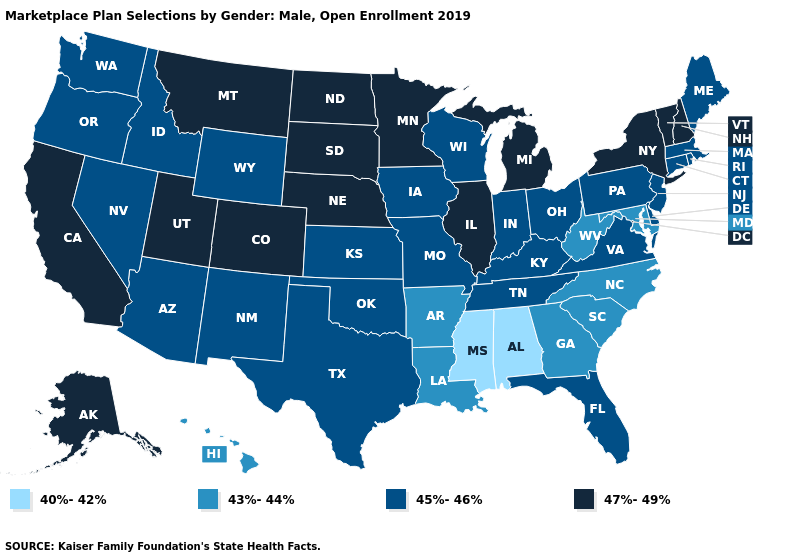Among the states that border Texas , which have the highest value?
Concise answer only. New Mexico, Oklahoma. Does Iowa have the lowest value in the USA?
Answer briefly. No. Name the states that have a value in the range 45%-46%?
Be succinct. Arizona, Connecticut, Delaware, Florida, Idaho, Indiana, Iowa, Kansas, Kentucky, Maine, Massachusetts, Missouri, Nevada, New Jersey, New Mexico, Ohio, Oklahoma, Oregon, Pennsylvania, Rhode Island, Tennessee, Texas, Virginia, Washington, Wisconsin, Wyoming. Does the first symbol in the legend represent the smallest category?
Write a very short answer. Yes. What is the value of Maine?
Answer briefly. 45%-46%. Name the states that have a value in the range 40%-42%?
Answer briefly. Alabama, Mississippi. What is the value of Ohio?
Concise answer only. 45%-46%. Name the states that have a value in the range 43%-44%?
Write a very short answer. Arkansas, Georgia, Hawaii, Louisiana, Maryland, North Carolina, South Carolina, West Virginia. What is the value of Maryland?
Be succinct. 43%-44%. What is the lowest value in states that border Iowa?
Quick response, please. 45%-46%. Which states hav the highest value in the South?
Quick response, please. Delaware, Florida, Kentucky, Oklahoma, Tennessee, Texas, Virginia. Which states have the lowest value in the USA?
Answer briefly. Alabama, Mississippi. What is the value of North Dakota?
Keep it brief. 47%-49%. What is the value of Connecticut?
Give a very brief answer. 45%-46%. Among the states that border Texas , does Louisiana have the lowest value?
Give a very brief answer. Yes. 